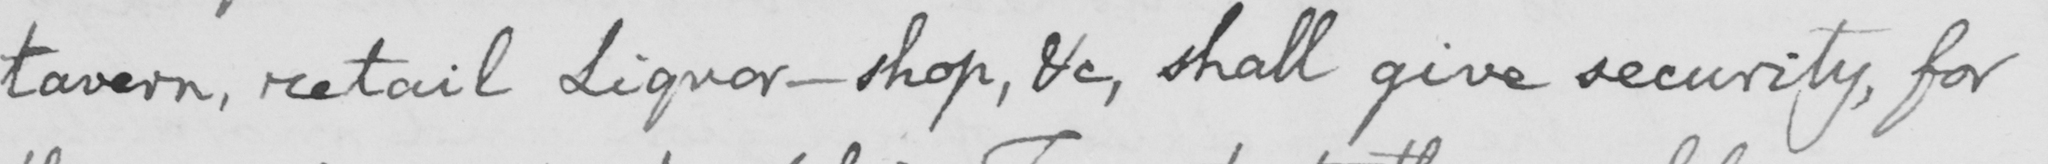Can you tell me what this handwritten text says? tavern , retail Liquor-shop , &c , shall give security , for 